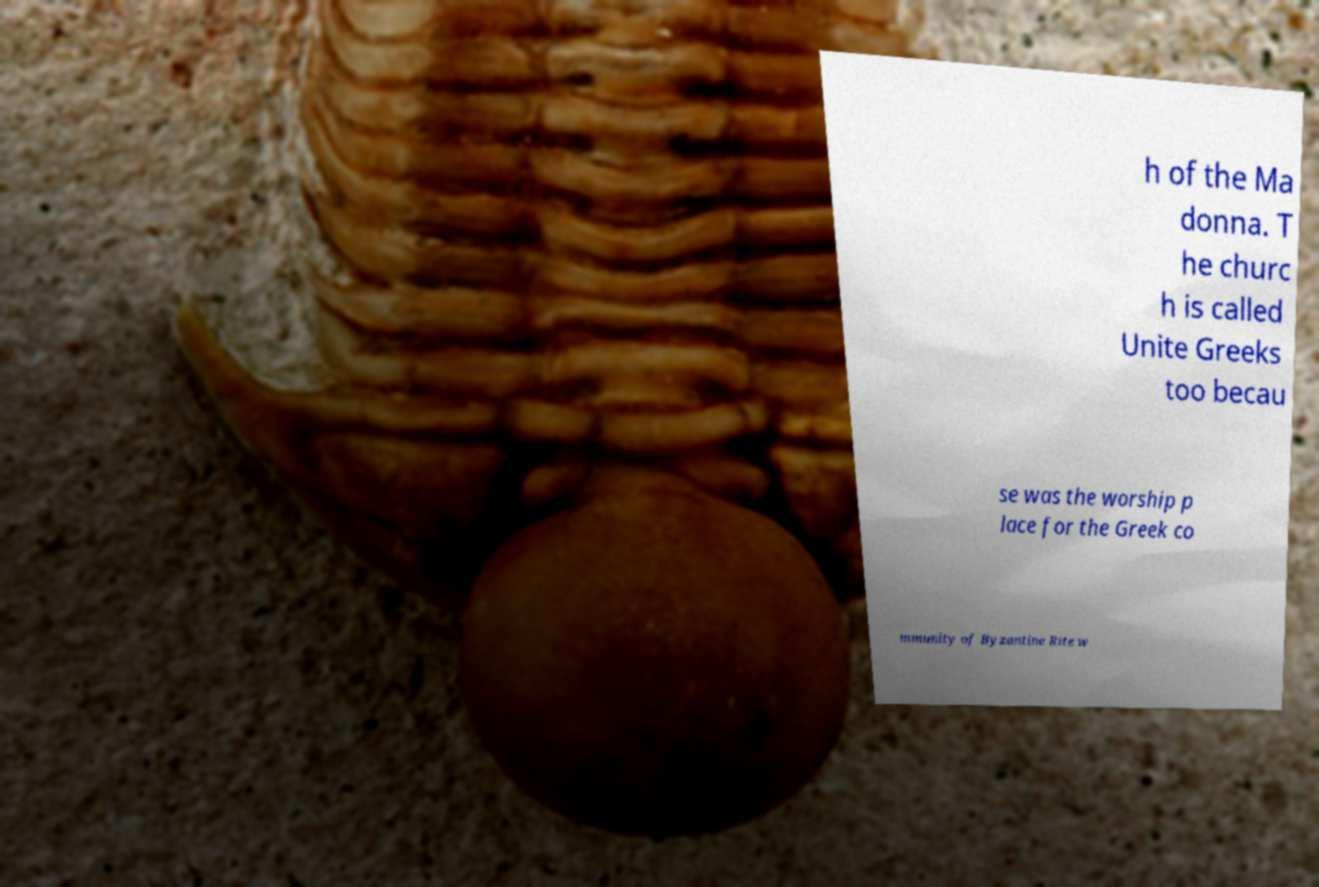Can you accurately transcribe the text from the provided image for me? h of the Ma donna. T he churc h is called Unite Greeks too becau se was the worship p lace for the Greek co mmunity of Byzantine Rite w 